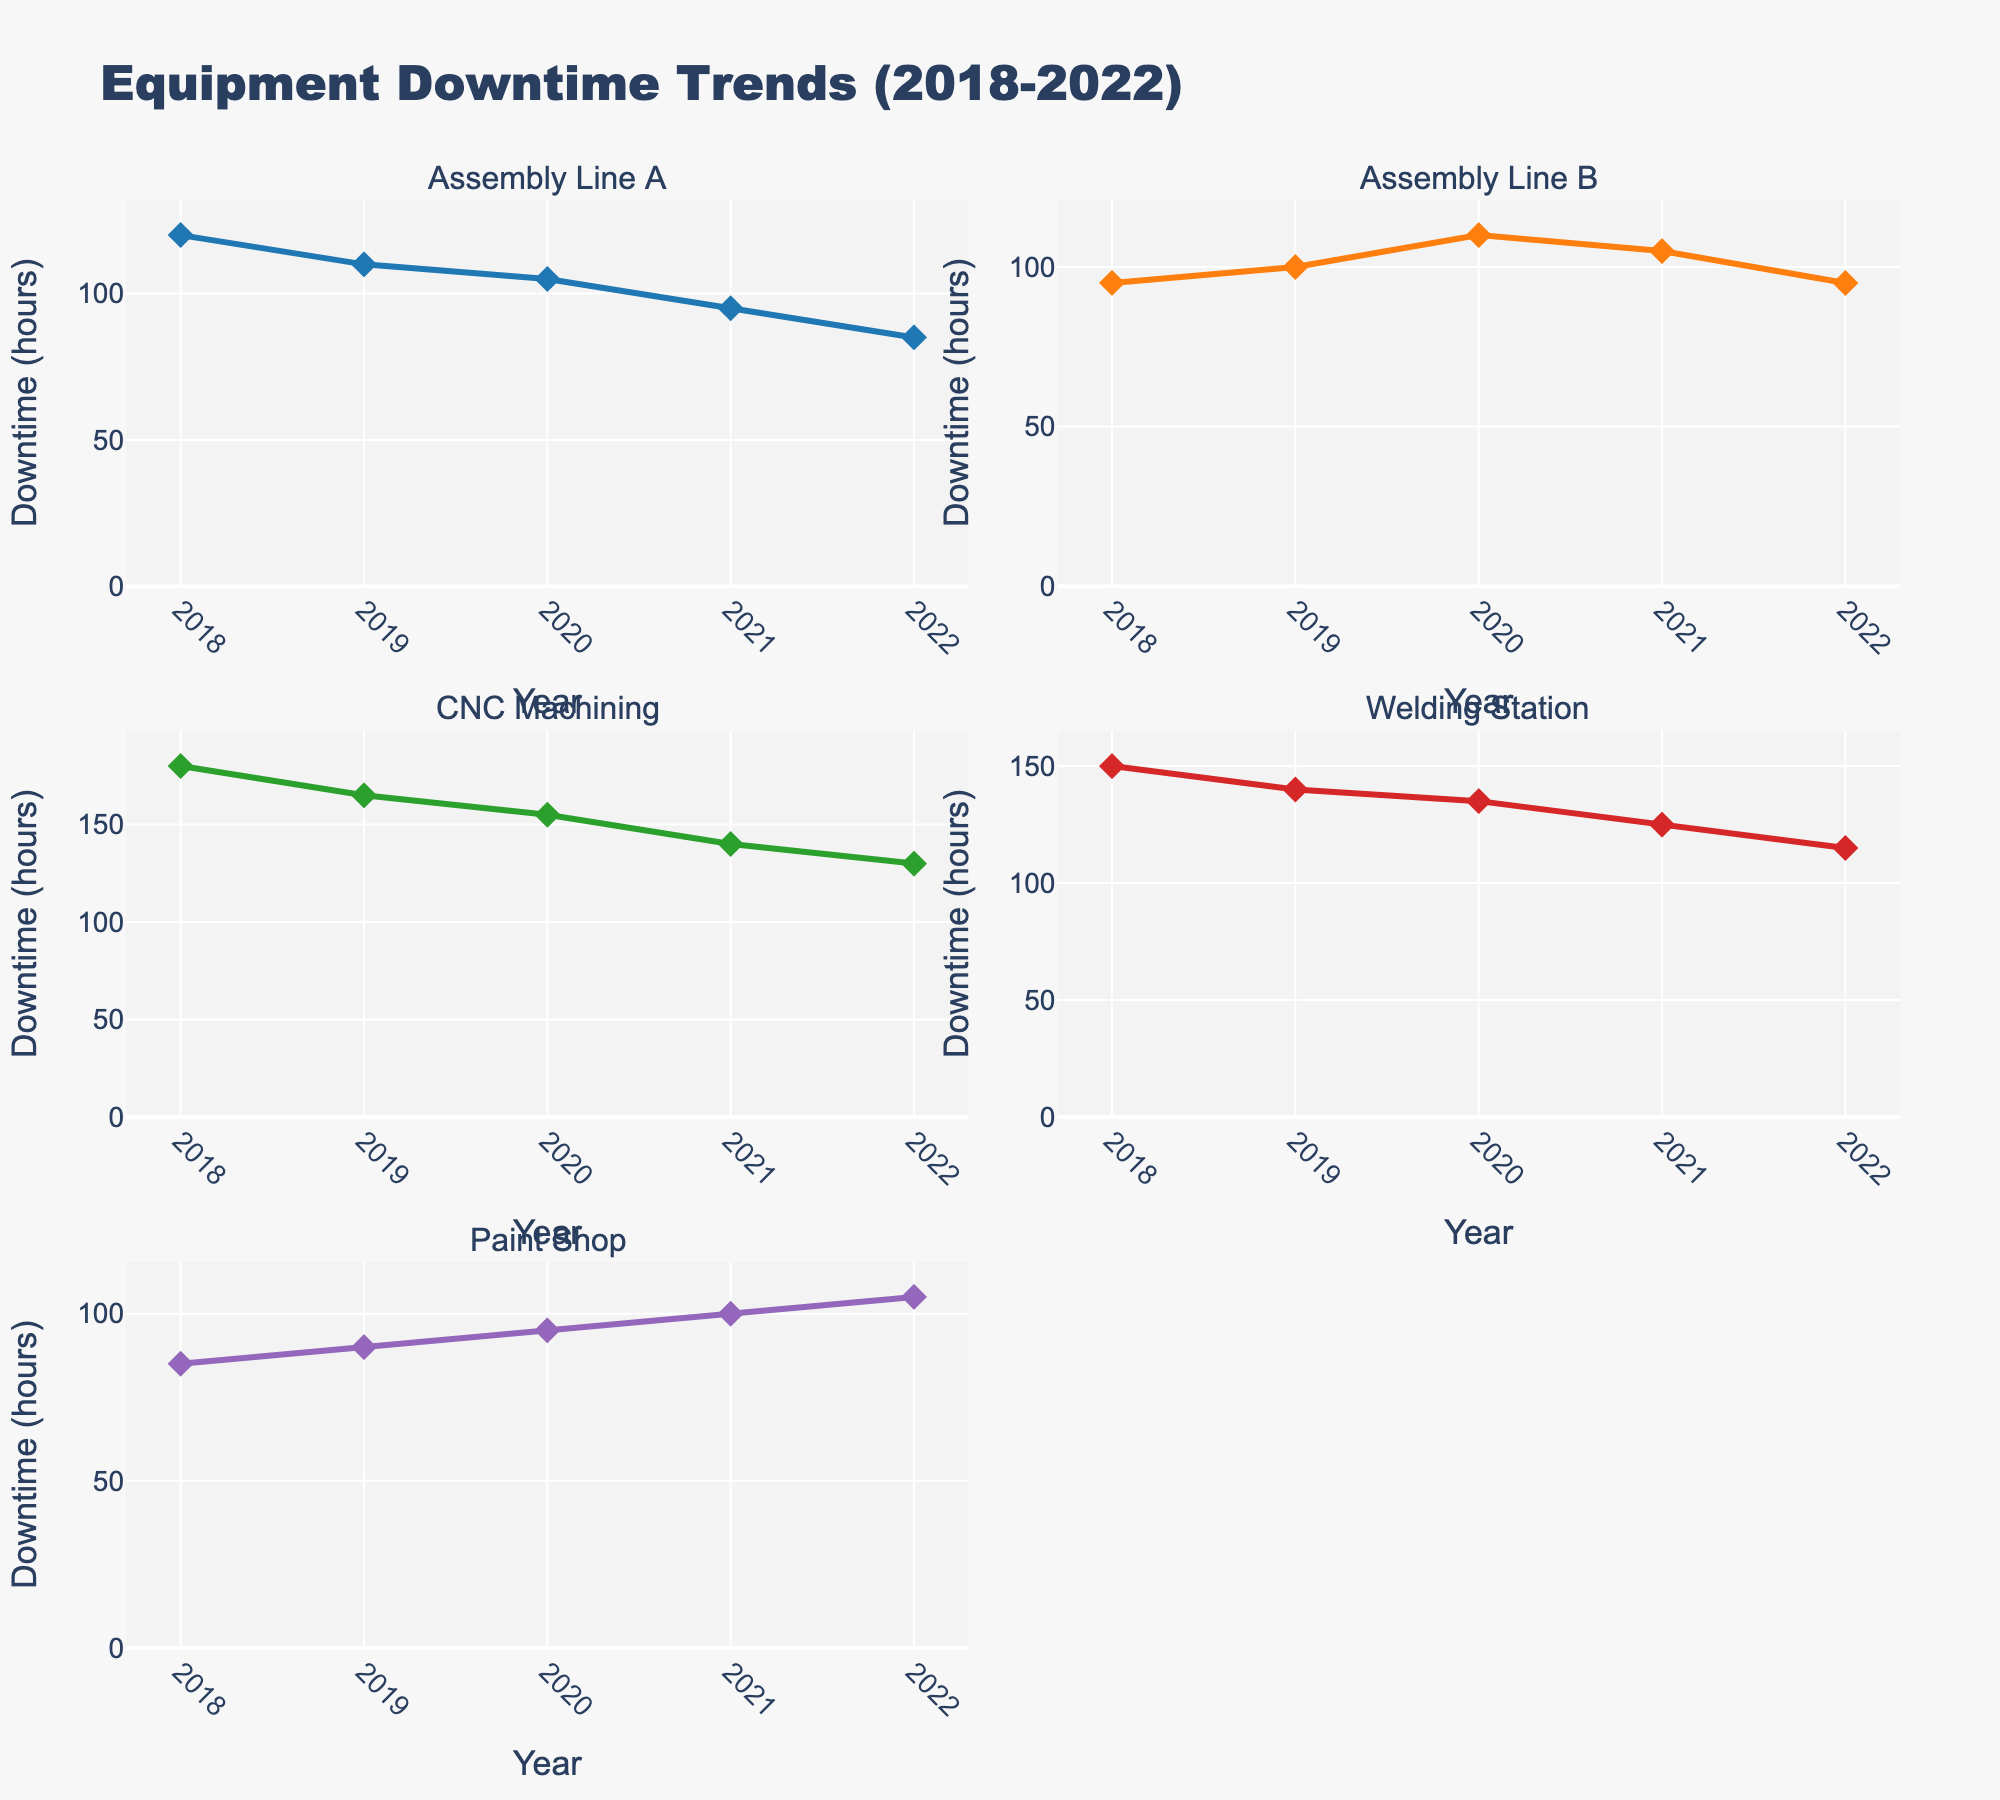What is the title of the figure? The title of the figure is located at the top and is the largest text in the chart, indicating the general topic.
Answer: Equipment Downtime Trends (2018-2022) Which assembly line had the highest downtime in 2019? By examining the data points on the graph and reading the value for each line in 2019, we can determine the highest point.
Answer: CNC Machining How did the downtime for the Paint Shop change from 2018 to 2022? Observe the trajectory of the line representing the Paint Shop from 2018 to 2022 and note the trend.
Answer: Increased What is the overall trend of downtime for Assembly Line A from 2018 to 2022? Look at the line representing Assembly Line A over the 5-year period and observe if it is generally increasing, decreasing, or stable.
Answer: Decreasing Between which consecutive years did Welding Station see the biggest drop in downtime? Compare the year-over-year differences for Welding Station and identify the largest drop.
Answer: 2020-2021 What was the downtime for the Welding Station in 2020 and how does it compare to 2022? Extract the values for Welding Station in 2020 and 2022 and compare them directly.
Answer: 155 in 2020; it decreased to 115 in 2022 Can you calculate the average downtime for CNC Machining over the 5-year period? Add the downtime values for CNC Machining from each year and divide by 5. (180 + 165 + 155 + 140 + 130) / 5 = 770 / 5 = 154
Answer: 154 Which manufacturing line had the most consistent (least variable) downtime from 2018 to 2022? Evaluate the variability of each line by observing the fluctuations in their trends and determine which one shows the least change.
Answer: Paint Shop In which year did Assembly Line B have the highest reduction in downtime compared to the previous year? Identify the year-over-year differences for Assembly Line B and locate the highest reduction.
Answer: 2021 How does the downtime trend for the Paint Shop compare with Assembly Line A? Analyze the lines for both the Paint Shop and Assembly Line A over the years and compare their slopes and directions.
Answer: Paint Shop is increasing, while Assembly Line A is decreasing 